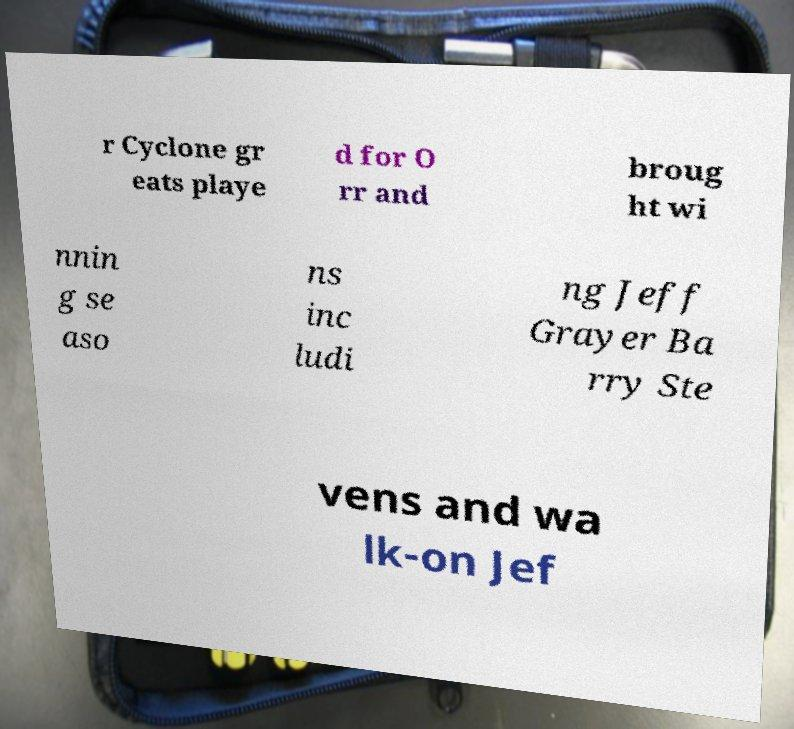Could you assist in decoding the text presented in this image and type it out clearly? r Cyclone gr eats playe d for O rr and broug ht wi nnin g se aso ns inc ludi ng Jeff Grayer Ba rry Ste vens and wa lk-on Jef 